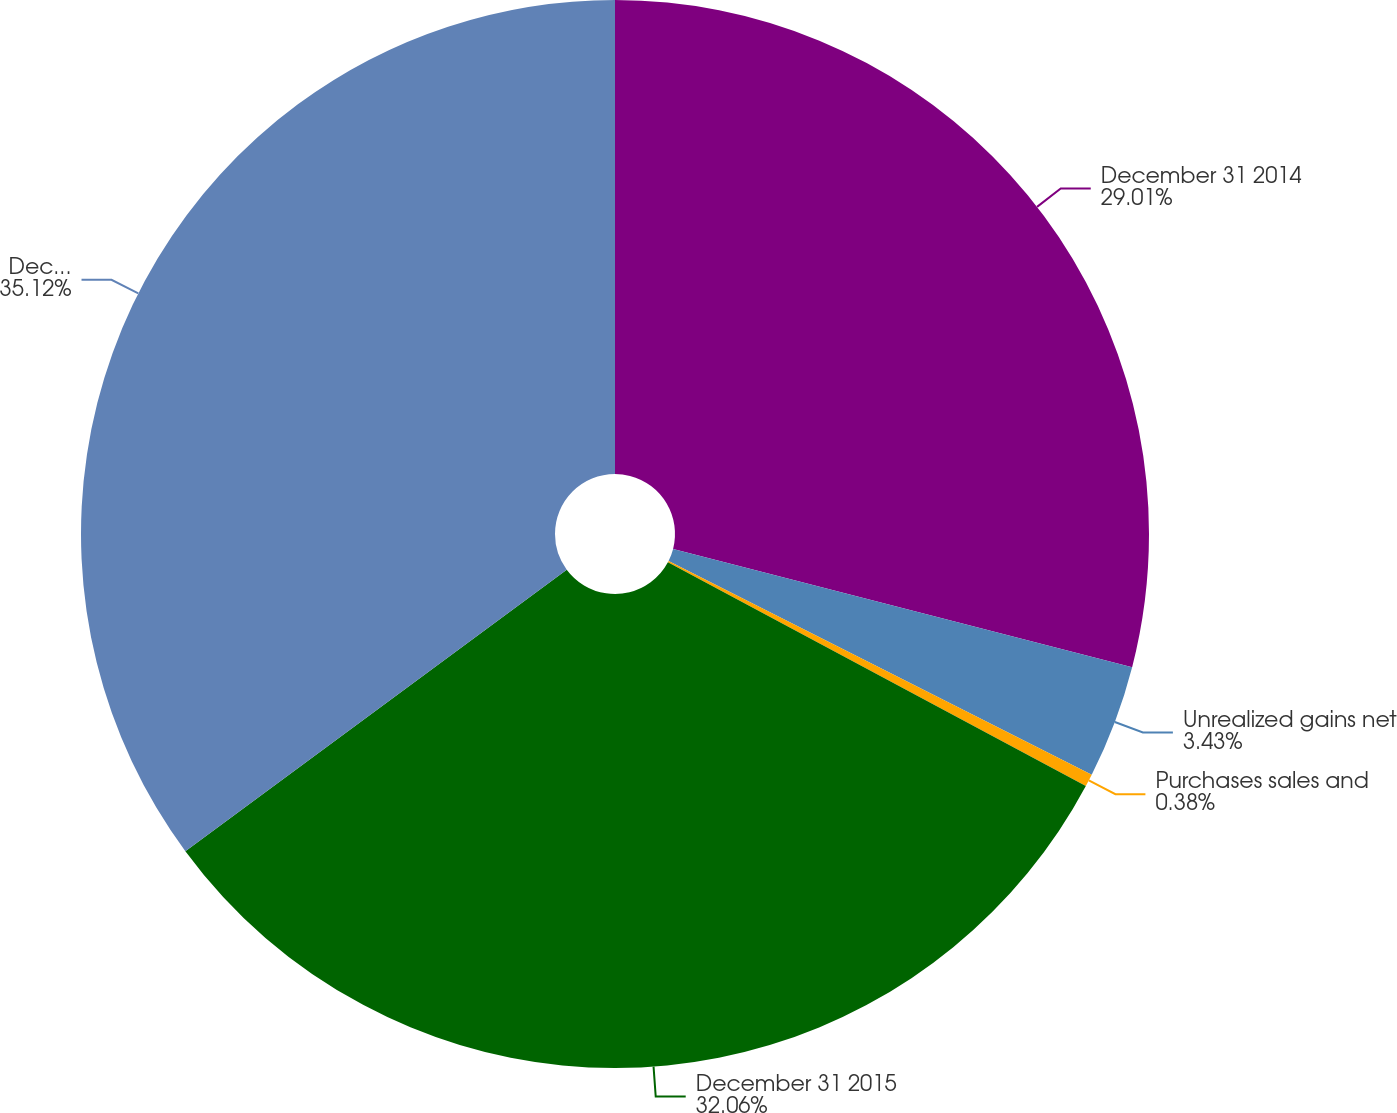Convert chart to OTSL. <chart><loc_0><loc_0><loc_500><loc_500><pie_chart><fcel>December 31 2014<fcel>Unrealized gains net<fcel>Purchases sales and<fcel>December 31 2015<fcel>December 31 2016<nl><fcel>29.01%<fcel>3.43%<fcel>0.38%<fcel>32.06%<fcel>35.12%<nl></chart> 